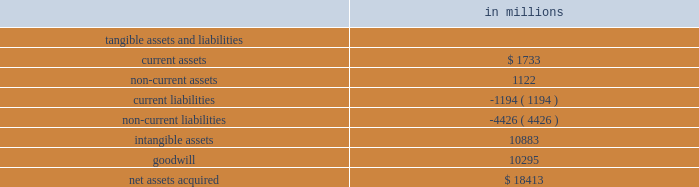Visa inc .
Notes to consolidated financial statements 2014 ( continued ) september 30 , 2009 ( in millions , except as noted ) to value the shares issued on june 15 , 2007 ( the 201cmeasurement date 201d ) , the company primarily relied upon the analysis of comparable companies with similar industry , business model and financial profiles .
This analysis considered a range of metrics including the forward multiples of revenue ; earnings before interest , depreciation and amortization ; and net income of these comparable companies .
Ultimately , the company determined that the forward net income multiple was the most appropriate measure to value the acquired regions and reflect anticipated changes in the company 2019s financial profile prospectively .
This multiple was applied to the corresponding forward net income of the acquired regions to calculate their value .
The most comparable company identified was mastercard inc .
Therefore , the most significant input into this analysis was mastercard 2019s forward net income multiple of 27 times net income at the measurement date .
Visa inc .
Common stock issued to visa europe as part of the reorganization , visa europe received 62762788 shares of class c ( series iii and iv ) common stock valued at $ 3.1 billion based on the value of the class c ( series i ) common stock issued to the acquired regions .
Visa europe also received 27904464 shares of class c ( series ii ) common stock valued at $ 1.104 billion determined by discounting the redemption price of these shares using a risk-free rate of 4.9% ( 4.9 % ) over the period to october 2008 , when these shares were redeemed by the company .
Prior to the ipo , the company issued visa europe an additional 51844393 class c ( series ii ) common stock at a price of $ 44 per share in exchange for a subscription receivable .
The issuance and subscription receivable were recorded as offsetting entries in temporary equity at september 30 , 2008 .
Completion of the company 2019s ipo triggered the redemption feature of this stock and in march 2008 , the company reclassified all outstanding shares of the class c ( series ii ) common stock at its then fair value of $ 1.125 billion to temporary equity on the consolidated balance sheet with a corresponding reduction in additional paid-in-capital of $ 1.104 billion and accumulated income of $ 21 million .
From march 2008 to october 10 , 2008 , the date these shares were redeemed , the company recorded accretion of this stock to its redemption price through accumulated income .
Fair value of assets acquired and liabilities assumed total purchase consideration has been allocated to the tangible and identifiable intangible assets and liabilities assumed underlying the acquired interests based on their fair value on the reorganization date .
The excess of purchase consideration over net assets assumed was recorded as goodwill .
The table summarizes this allocation. .

What was the percent of the net assets acquired allocated to current assets? 
Computations: (1733 / 18413)
Answer: 0.09412. 